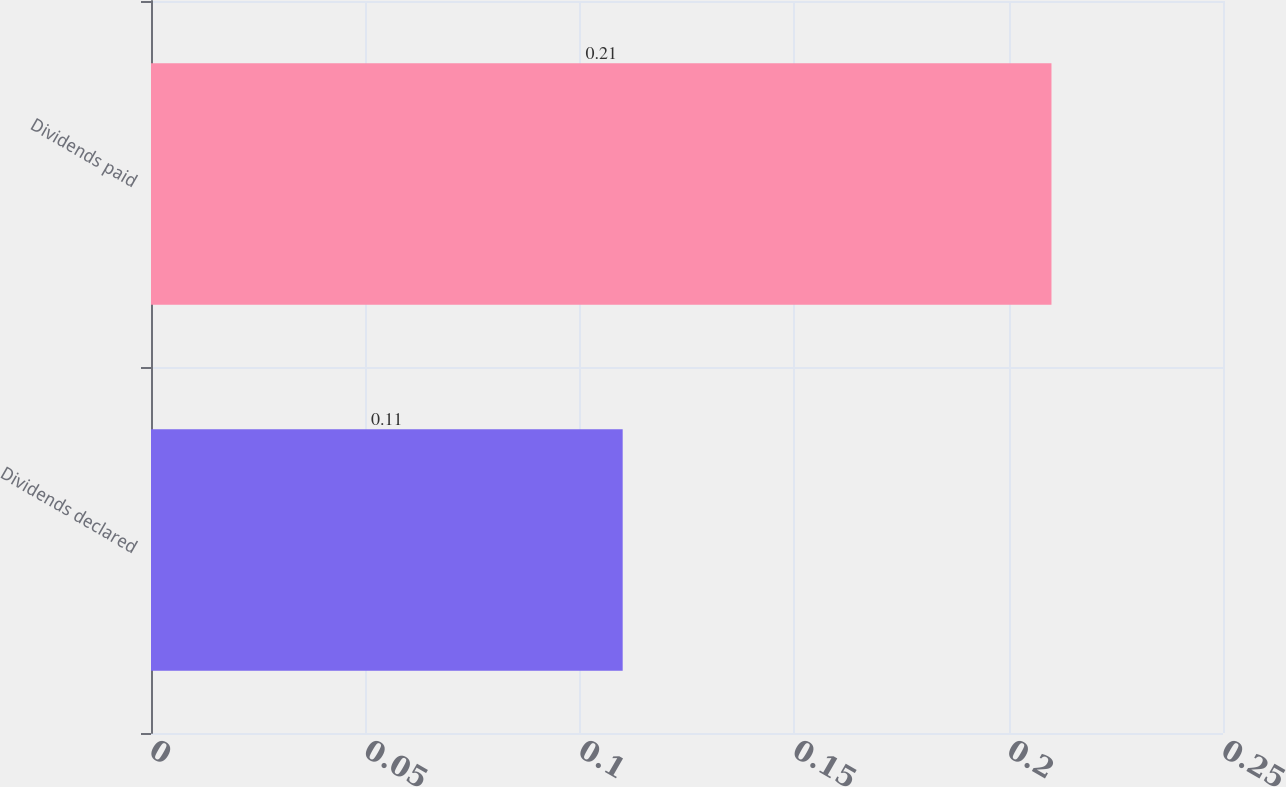<chart> <loc_0><loc_0><loc_500><loc_500><bar_chart><fcel>Dividends declared<fcel>Dividends paid<nl><fcel>0.11<fcel>0.21<nl></chart> 